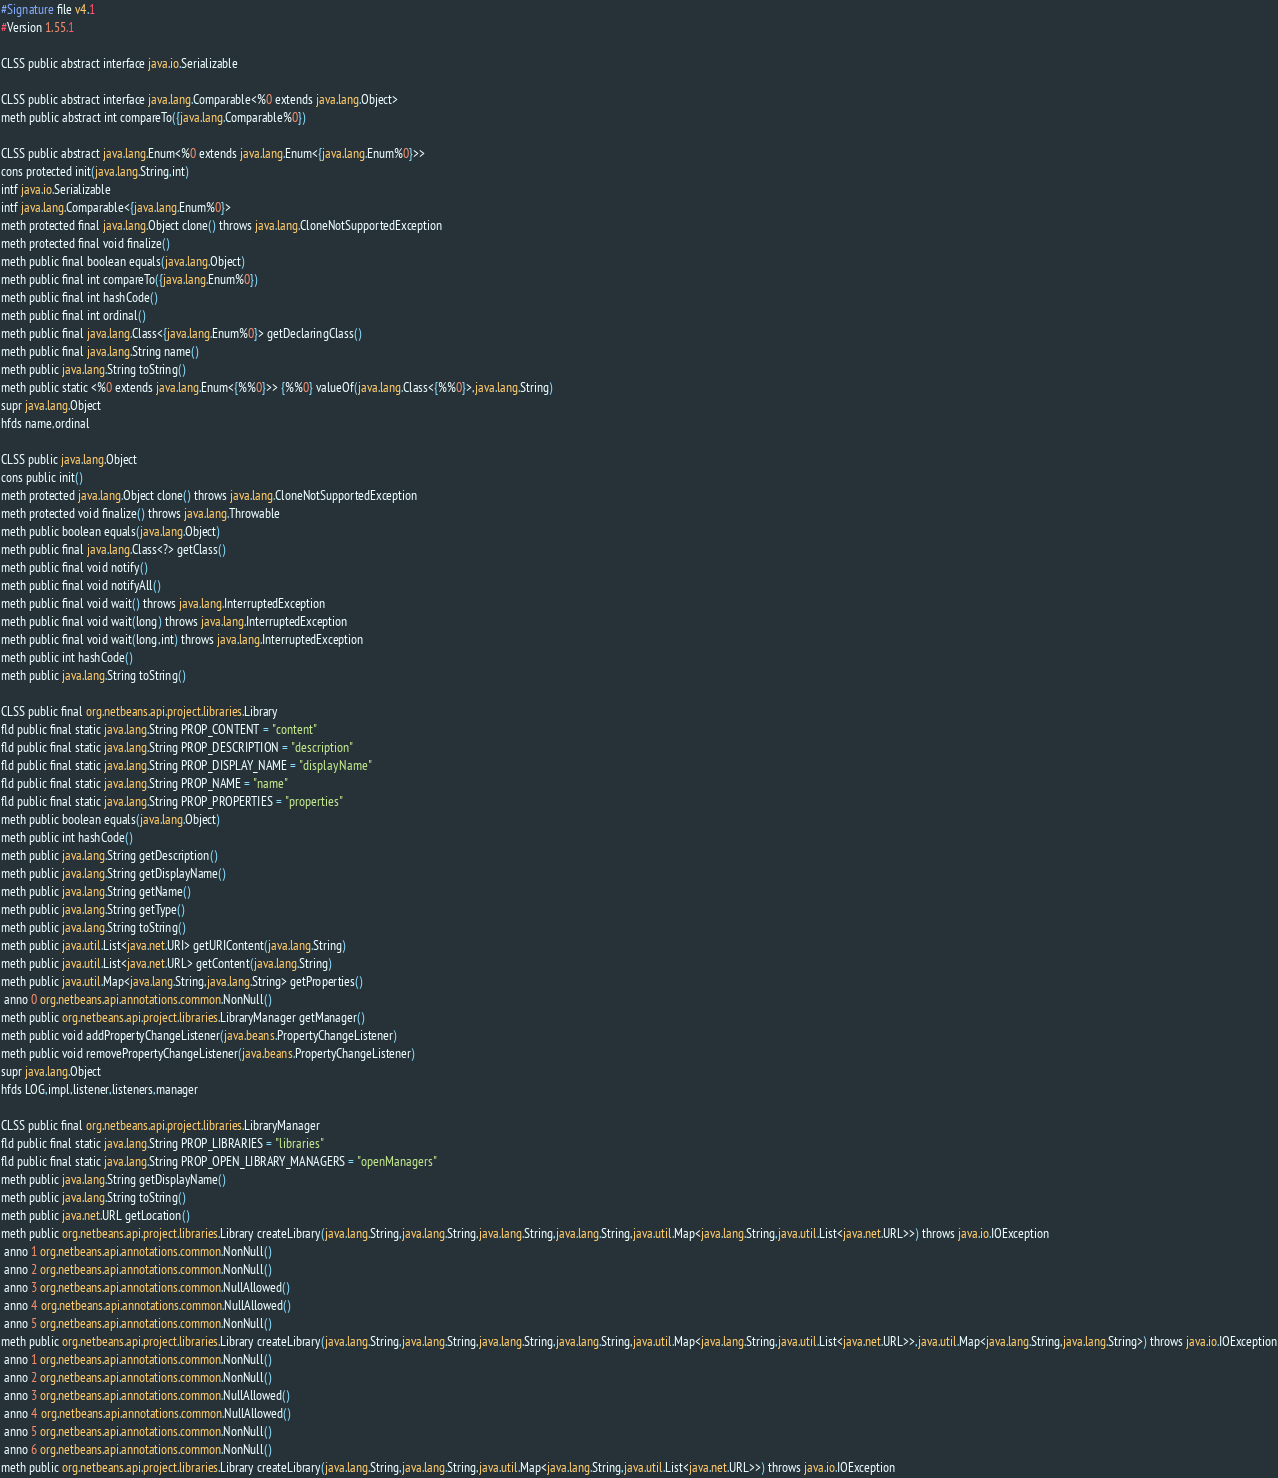Convert code to text. <code><loc_0><loc_0><loc_500><loc_500><_SML_>#Signature file v4.1
#Version 1.55.1

CLSS public abstract interface java.io.Serializable

CLSS public abstract interface java.lang.Comparable<%0 extends java.lang.Object>
meth public abstract int compareTo({java.lang.Comparable%0})

CLSS public abstract java.lang.Enum<%0 extends java.lang.Enum<{java.lang.Enum%0}>>
cons protected init(java.lang.String,int)
intf java.io.Serializable
intf java.lang.Comparable<{java.lang.Enum%0}>
meth protected final java.lang.Object clone() throws java.lang.CloneNotSupportedException
meth protected final void finalize()
meth public final boolean equals(java.lang.Object)
meth public final int compareTo({java.lang.Enum%0})
meth public final int hashCode()
meth public final int ordinal()
meth public final java.lang.Class<{java.lang.Enum%0}> getDeclaringClass()
meth public final java.lang.String name()
meth public java.lang.String toString()
meth public static <%0 extends java.lang.Enum<{%%0}>> {%%0} valueOf(java.lang.Class<{%%0}>,java.lang.String)
supr java.lang.Object
hfds name,ordinal

CLSS public java.lang.Object
cons public init()
meth protected java.lang.Object clone() throws java.lang.CloneNotSupportedException
meth protected void finalize() throws java.lang.Throwable
meth public boolean equals(java.lang.Object)
meth public final java.lang.Class<?> getClass()
meth public final void notify()
meth public final void notifyAll()
meth public final void wait() throws java.lang.InterruptedException
meth public final void wait(long) throws java.lang.InterruptedException
meth public final void wait(long,int) throws java.lang.InterruptedException
meth public int hashCode()
meth public java.lang.String toString()

CLSS public final org.netbeans.api.project.libraries.Library
fld public final static java.lang.String PROP_CONTENT = "content"
fld public final static java.lang.String PROP_DESCRIPTION = "description"
fld public final static java.lang.String PROP_DISPLAY_NAME = "displayName"
fld public final static java.lang.String PROP_NAME = "name"
fld public final static java.lang.String PROP_PROPERTIES = "properties"
meth public boolean equals(java.lang.Object)
meth public int hashCode()
meth public java.lang.String getDescription()
meth public java.lang.String getDisplayName()
meth public java.lang.String getName()
meth public java.lang.String getType()
meth public java.lang.String toString()
meth public java.util.List<java.net.URI> getURIContent(java.lang.String)
meth public java.util.List<java.net.URL> getContent(java.lang.String)
meth public java.util.Map<java.lang.String,java.lang.String> getProperties()
 anno 0 org.netbeans.api.annotations.common.NonNull()
meth public org.netbeans.api.project.libraries.LibraryManager getManager()
meth public void addPropertyChangeListener(java.beans.PropertyChangeListener)
meth public void removePropertyChangeListener(java.beans.PropertyChangeListener)
supr java.lang.Object
hfds LOG,impl,listener,listeners,manager

CLSS public final org.netbeans.api.project.libraries.LibraryManager
fld public final static java.lang.String PROP_LIBRARIES = "libraries"
fld public final static java.lang.String PROP_OPEN_LIBRARY_MANAGERS = "openManagers"
meth public java.lang.String getDisplayName()
meth public java.lang.String toString()
meth public java.net.URL getLocation()
meth public org.netbeans.api.project.libraries.Library createLibrary(java.lang.String,java.lang.String,java.lang.String,java.lang.String,java.util.Map<java.lang.String,java.util.List<java.net.URL>>) throws java.io.IOException
 anno 1 org.netbeans.api.annotations.common.NonNull()
 anno 2 org.netbeans.api.annotations.common.NonNull()
 anno 3 org.netbeans.api.annotations.common.NullAllowed()
 anno 4 org.netbeans.api.annotations.common.NullAllowed()
 anno 5 org.netbeans.api.annotations.common.NonNull()
meth public org.netbeans.api.project.libraries.Library createLibrary(java.lang.String,java.lang.String,java.lang.String,java.lang.String,java.util.Map<java.lang.String,java.util.List<java.net.URL>>,java.util.Map<java.lang.String,java.lang.String>) throws java.io.IOException
 anno 1 org.netbeans.api.annotations.common.NonNull()
 anno 2 org.netbeans.api.annotations.common.NonNull()
 anno 3 org.netbeans.api.annotations.common.NullAllowed()
 anno 4 org.netbeans.api.annotations.common.NullAllowed()
 anno 5 org.netbeans.api.annotations.common.NonNull()
 anno 6 org.netbeans.api.annotations.common.NonNull()
meth public org.netbeans.api.project.libraries.Library createLibrary(java.lang.String,java.lang.String,java.util.Map<java.lang.String,java.util.List<java.net.URL>>) throws java.io.IOException</code> 